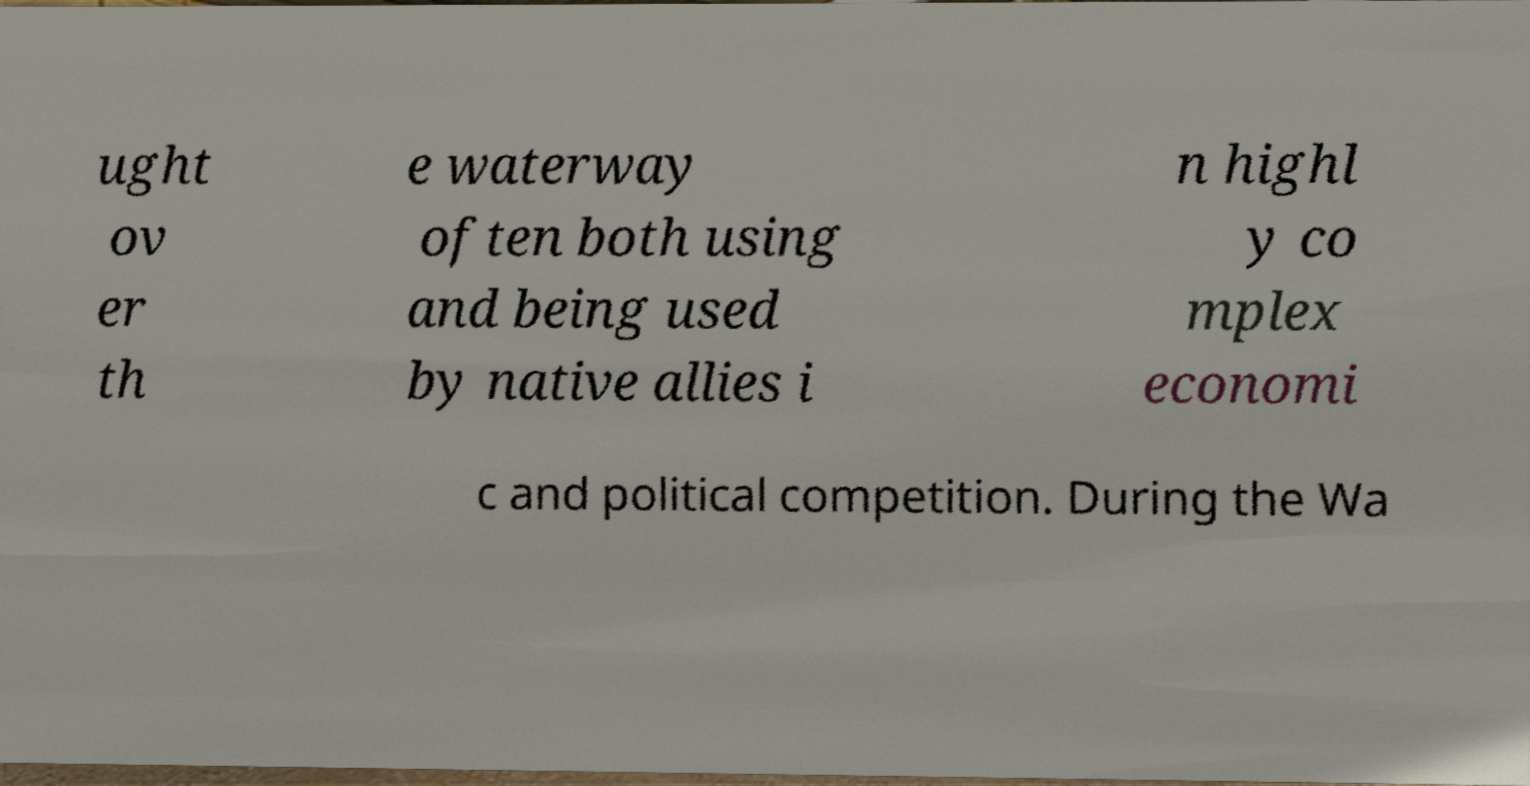What messages or text are displayed in this image? I need them in a readable, typed format. ught ov er th e waterway often both using and being used by native allies i n highl y co mplex economi c and political competition. During the Wa 